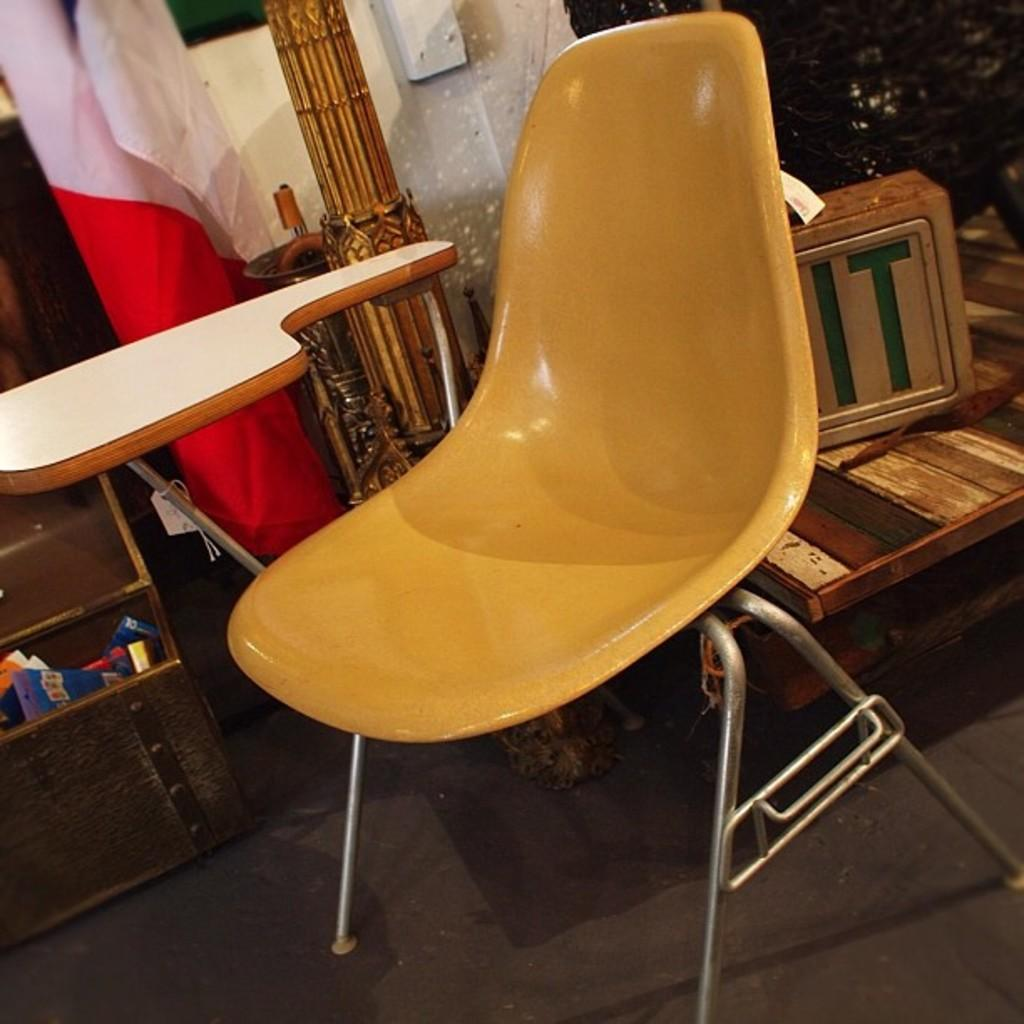What type of chair is in the image? There is a yellow chair in the image. What material is the table made of in the image? The table in the image is made of iron. Where is the iron table located in relation to the yellow chair? The iron table is beside the yellow chair. What objects can be seen on the right side of the image? There are wooden boxes on the right side of the image. What can be seen near a rack on the left side of the image? There is a flag near a rack on the left side of the image. Is there any grass visible in the image? No, there is no grass present in the image. What type of furniture is on fire in the image? There is no furniture on fire in the image. 